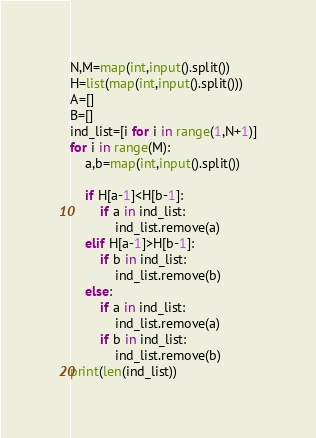<code> <loc_0><loc_0><loc_500><loc_500><_Python_>N,M=map(int,input().split())
H=list(map(int,input().split()))
A=[]
B=[]
ind_list=[i for i in range(1,N+1)]
for i in range(M):
    a,b=map(int,input().split())

    if H[a-1]<H[b-1]:
        if a in ind_list:
            ind_list.remove(a)
    elif H[a-1]>H[b-1]:
        if b in ind_list:
            ind_list.remove(b)
    else:
        if a in ind_list:
            ind_list.remove(a)
        if b in ind_list:
            ind_list.remove(b)
print(len(ind_list))</code> 